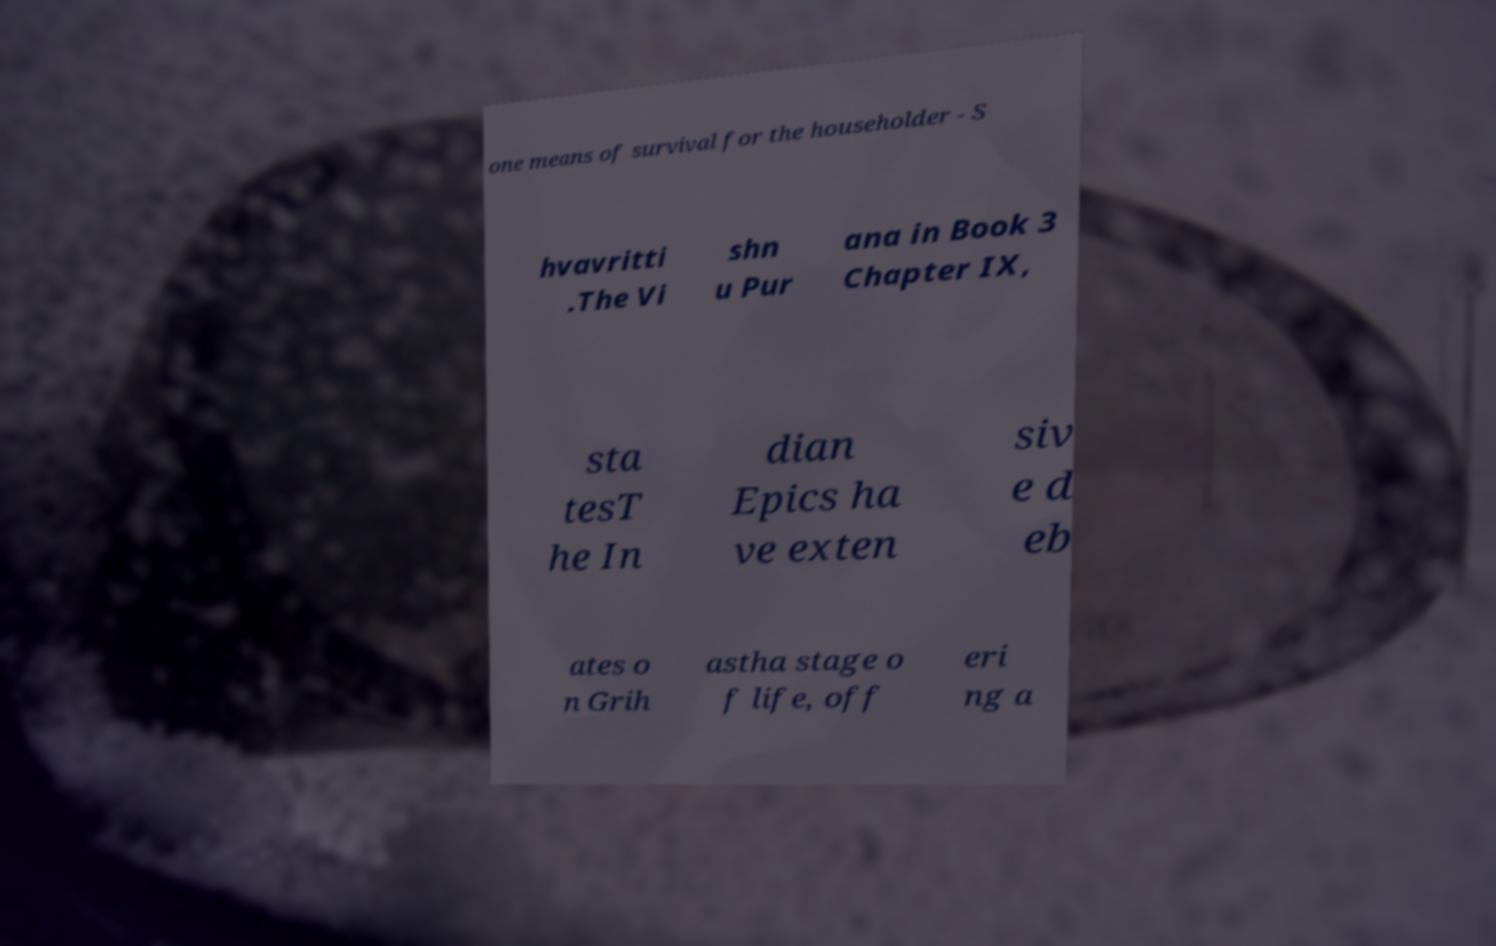Please identify and transcribe the text found in this image. one means of survival for the householder - S hvavritti .The Vi shn u Pur ana in Book 3 Chapter IX, sta tesT he In dian Epics ha ve exten siv e d eb ates o n Grih astha stage o f life, off eri ng a 